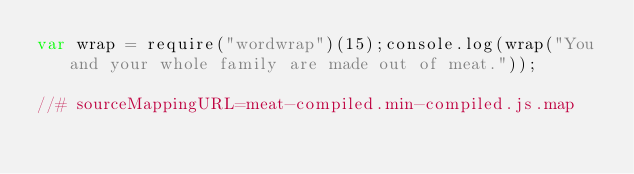<code> <loc_0><loc_0><loc_500><loc_500><_JavaScript_>var wrap = require("wordwrap")(15);console.log(wrap("You and your whole family are made out of meat."));

//# sourceMappingURL=meat-compiled.min-compiled.js.map</code> 